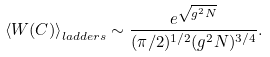Convert formula to latex. <formula><loc_0><loc_0><loc_500><loc_500>\left < W ( C ) \right > _ { l a d d e r s } \sim \frac { e ^ { \sqrt { g ^ { 2 } N } } } { ( \pi / 2 ) ^ { 1 / 2 } ( g ^ { 2 } N ) ^ { 3 / 4 } } .</formula> 